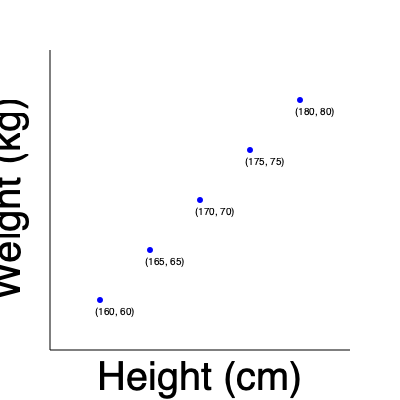As a health-conscious resident of Thetford, you're analyzing a scatter plot of height and weight data for local residents. Calculate the average BMI of the population represented in this plot. Round your answer to one decimal place. (Note: BMI = weight (kg) / (height (m))²) To calculate the average BMI:

1. Calculate BMI for each data point:
   a) (160 cm, 60 kg): BMI = 60 / (1.60)² = 23.4
   b) (165 cm, 65 kg): BMI = 65 / (1.65)² = 23.9
   c) (170 cm, 70 kg): BMI = 70 / (1.70)² = 24.2
   d) (175 cm, 75 kg): BMI = 75 / (1.75)² = 24.5
   e) (180 cm, 80 kg): BMI = 80 / (1.80)² = 24.7

2. Sum all BMI values:
   23.4 + 23.9 + 24.2 + 24.5 + 24.7 = 120.7

3. Divide by the number of data points (5):
   120.7 / 5 = 24.14

4. Round to one decimal place:
   24.1

Therefore, the average BMI of the Thetford residents represented in this plot is 24.1.
Answer: 24.1 